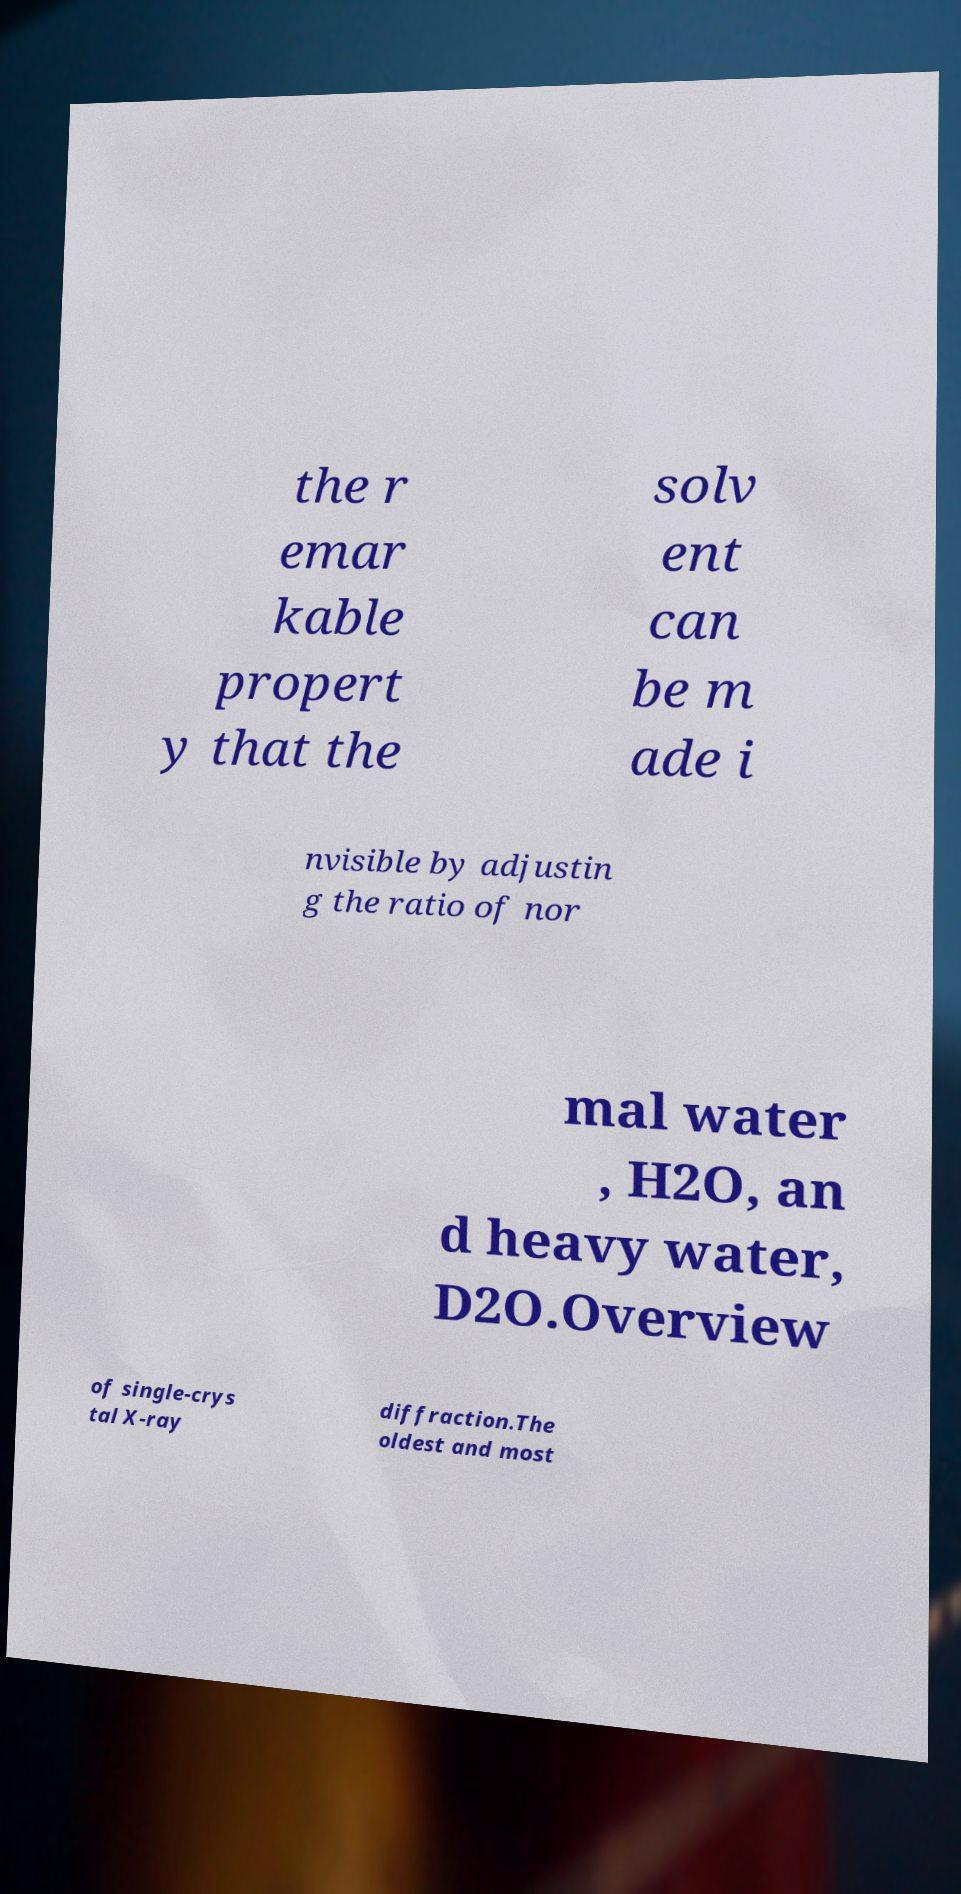Please read and relay the text visible in this image. What does it say? the r emar kable propert y that the solv ent can be m ade i nvisible by adjustin g the ratio of nor mal water , H2O, an d heavy water, D2O.Overview of single-crys tal X-ray diffraction.The oldest and most 